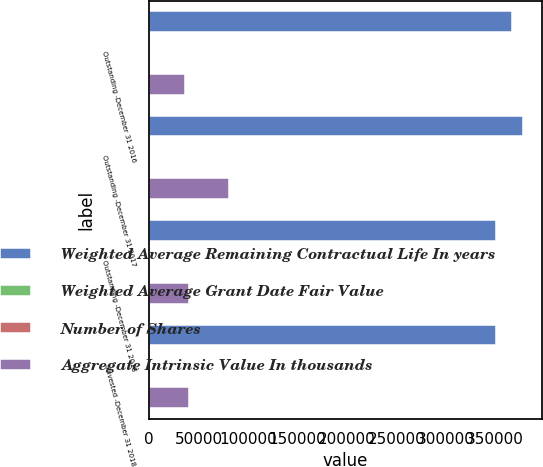Convert chart. <chart><loc_0><loc_0><loc_500><loc_500><stacked_bar_chart><ecel><fcel>Outstanding -December 31 2016<fcel>Outstanding -December 31 2017<fcel>Outstanding -December 31 2018<fcel>Unvested -December 31 2018<nl><fcel>Weighted Average Remaining Contractual Life In years<fcel>366770<fcel>378261<fcel>351021<fcel>351021<nl><fcel>Weighted Average Grant Date Fair Value<fcel>79.72<fcel>96.23<fcel>126.93<fcel>126.93<nl><fcel>Number of Shares<fcel>2.55<fcel>2.55<fcel>2.62<fcel>2.62<nl><fcel>Aggregate Intrinsic Value In thousands<fcel>36204<fcel>80997<fcel>39767<fcel>39767<nl></chart> 